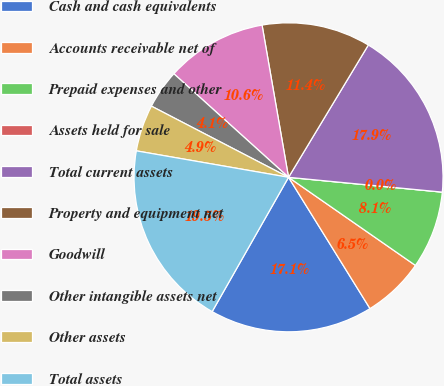Convert chart to OTSL. <chart><loc_0><loc_0><loc_500><loc_500><pie_chart><fcel>Cash and cash equivalents<fcel>Accounts receivable net of<fcel>Prepaid expenses and other<fcel>Assets held for sale<fcel>Total current assets<fcel>Property and equipment net<fcel>Goodwill<fcel>Other intangible assets net<fcel>Other assets<fcel>Total assets<nl><fcel>17.07%<fcel>6.5%<fcel>8.13%<fcel>0.0%<fcel>17.89%<fcel>11.38%<fcel>10.57%<fcel>4.07%<fcel>4.88%<fcel>19.51%<nl></chart> 